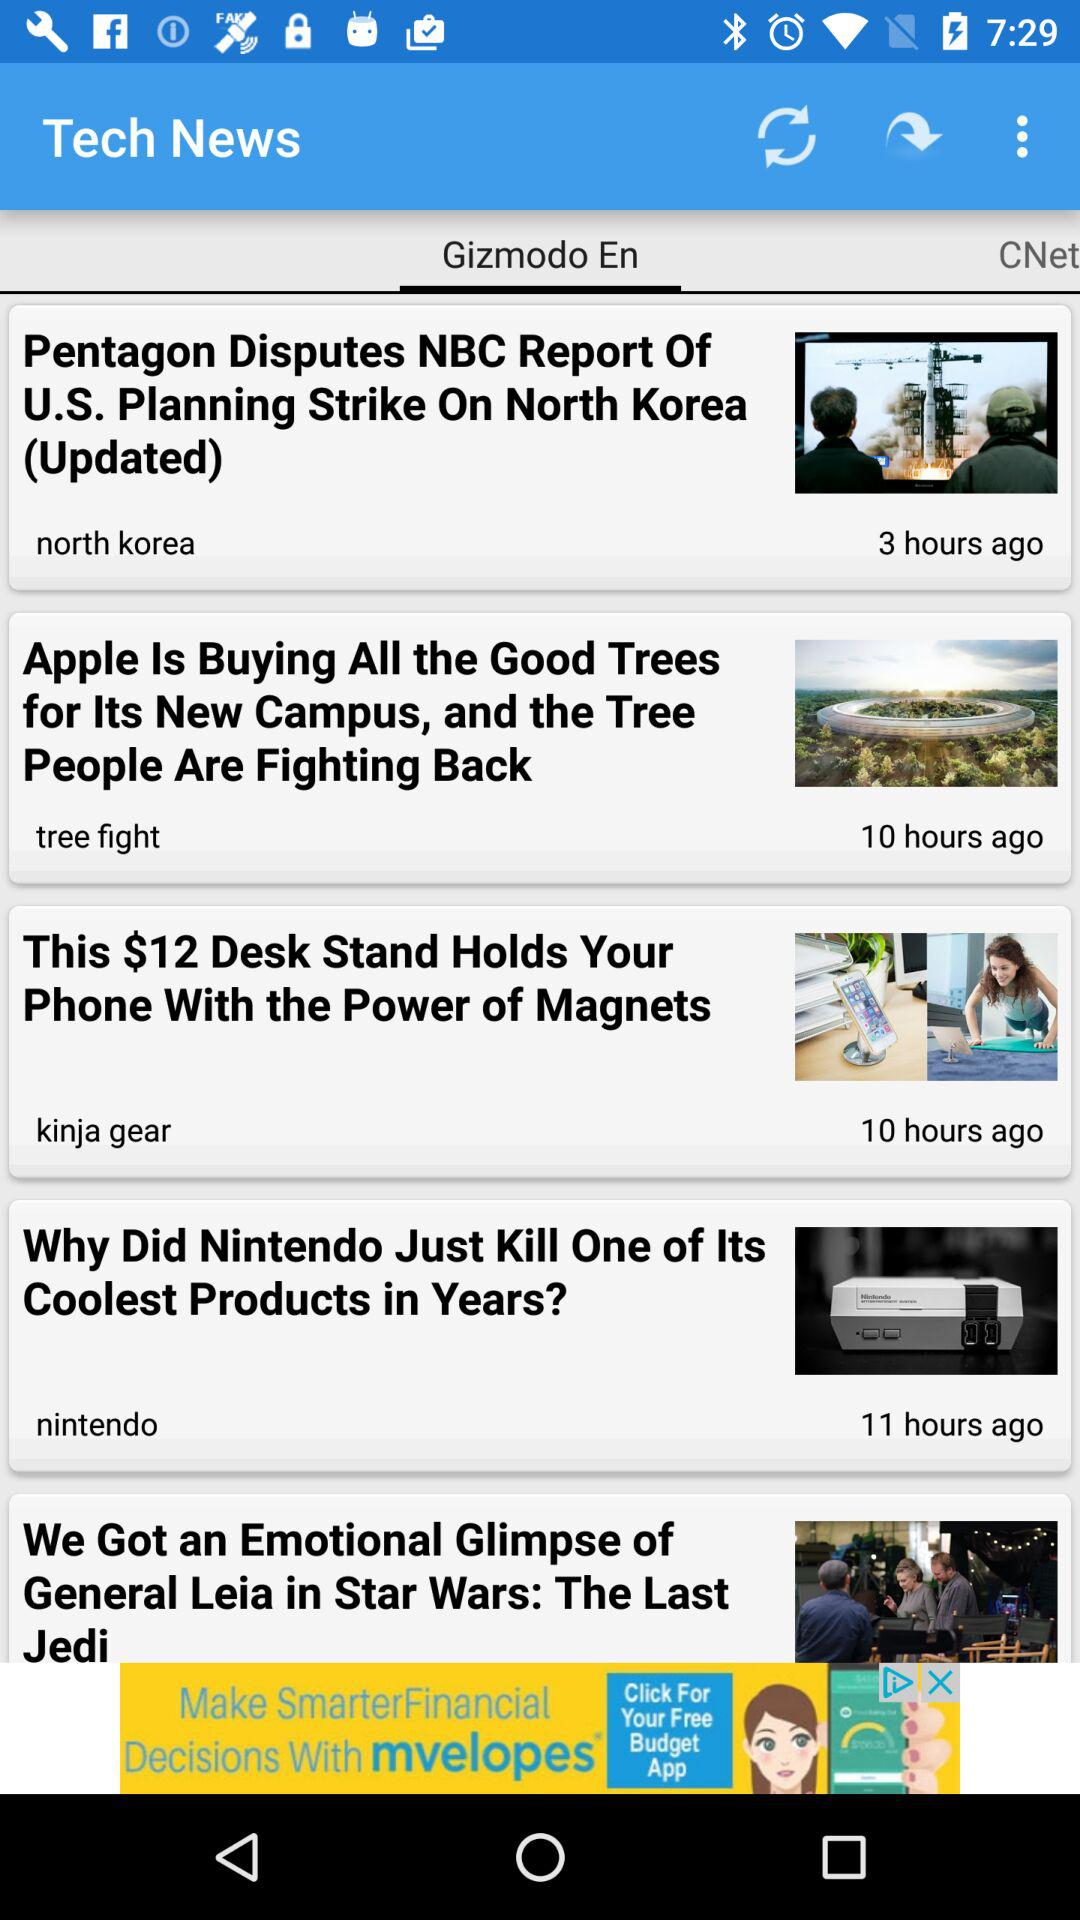How many hours ago was the news posted by Kinja Gear? Kinja Gear posted the news 10 hours ago. 